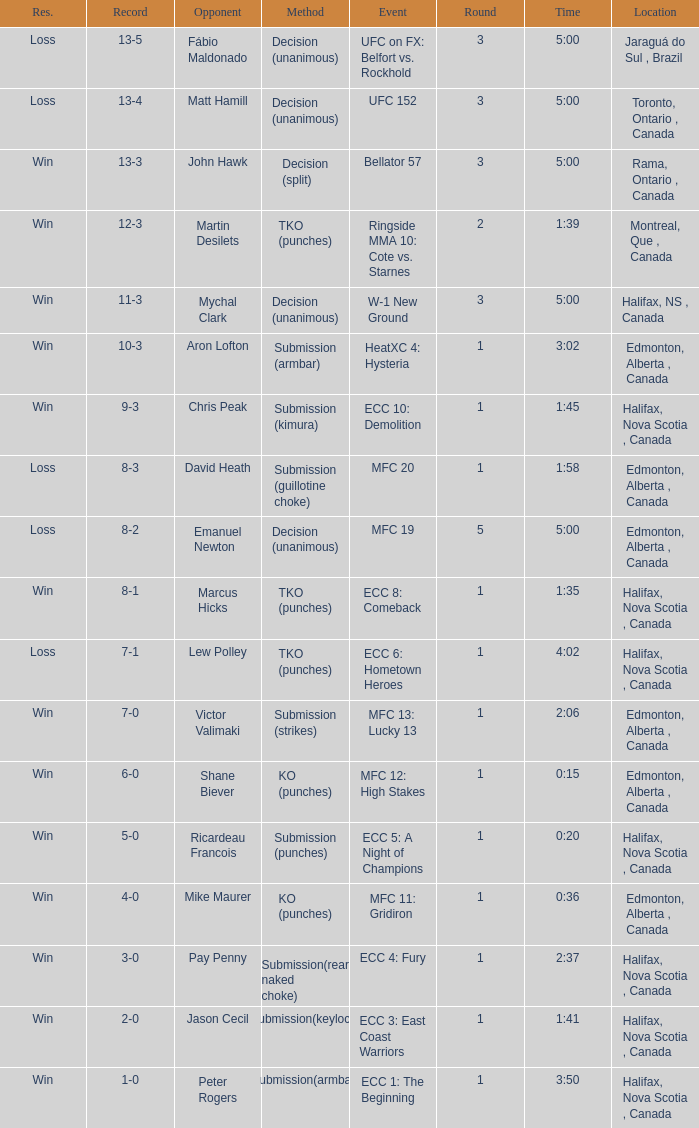What is the portion of the fight involving emanuel newton as the opposition? 5.0. 